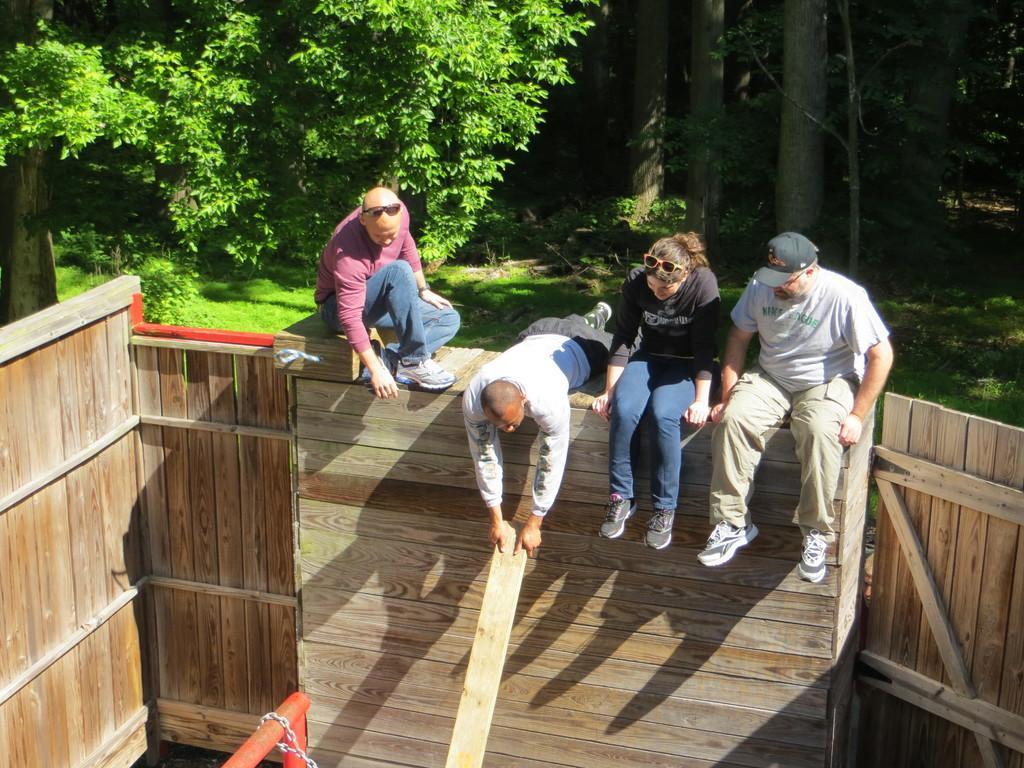In one or two sentences, can you explain what this image depicts? In this image there is a wooden surface on that three persons are sitting and one person is lying, in the background there are trees. 